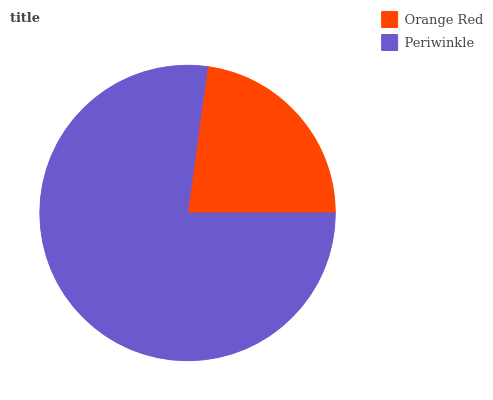Is Orange Red the minimum?
Answer yes or no. Yes. Is Periwinkle the maximum?
Answer yes or no. Yes. Is Periwinkle the minimum?
Answer yes or no. No. Is Periwinkle greater than Orange Red?
Answer yes or no. Yes. Is Orange Red less than Periwinkle?
Answer yes or no. Yes. Is Orange Red greater than Periwinkle?
Answer yes or no. No. Is Periwinkle less than Orange Red?
Answer yes or no. No. Is Periwinkle the high median?
Answer yes or no. Yes. Is Orange Red the low median?
Answer yes or no. Yes. Is Orange Red the high median?
Answer yes or no. No. Is Periwinkle the low median?
Answer yes or no. No. 